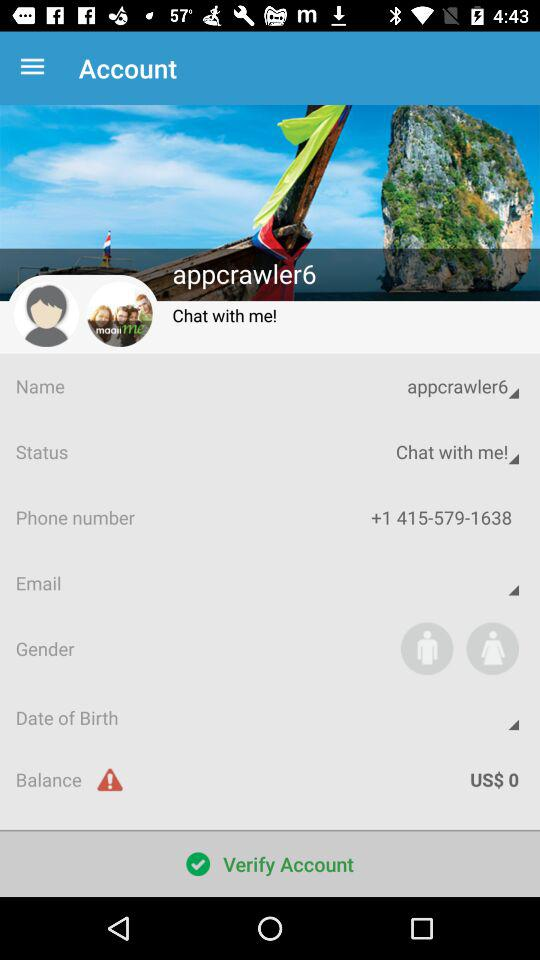What is the balance? The balance is US$ 0. 